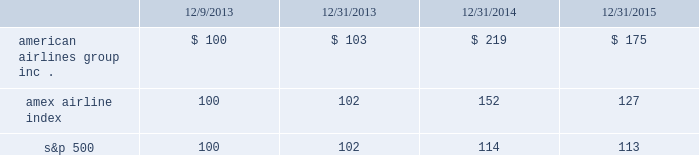Table of contents capital deployment program will be subject to market and economic conditions , applicable legal requirements and other relevant factors .
Our capital deployment program does not obligate us to continue a dividend for any fixed period , and payment of dividends may be suspended at any time at our discretion .
Stock performance graph the following stock performance graph and related information shall not be deemed 201csoliciting material 201d or 201cfiled 201d with the securities and exchange commission , nor shall such information be incorporated by reference into any future filings under the securities act of 1933 or the exchange act , each as amended , except to the extent that we specifically incorporate it by reference into such filing .
The following stock performance graph compares our cumulative total stockholder return on an annual basis on our common stock with the cumulative total return on the standard and poor 2019s 500 stock index and the amex airline index from december 9 , 2013 ( the first trading day of aag common stock ) through december 31 , 2015 .
The comparison assumes $ 100 was invested on december 9 , 2013 in aag common stock and in each of the foregoing indices and assumes reinvestment of dividends .
The stock performance shown on the graph below represents historical stock performance and is not necessarily indicative of future stock price performance. .
Purchases of equity securities by the issuer and affiliated purchasers since july 2014 , our board of directors has approved several share repurchase programs aggregating $ 7.0 billion of authority of which , as of december 31 , 2015 , $ 2.4 billion remained unused under repurchase programs .
By how much did american airlines group inc . common stock out preform the s&p 500 index over the 4 year period? 
Computations: (((175 - 100) / 100) - ((127 - 100) / 100))
Answer: 0.48. 